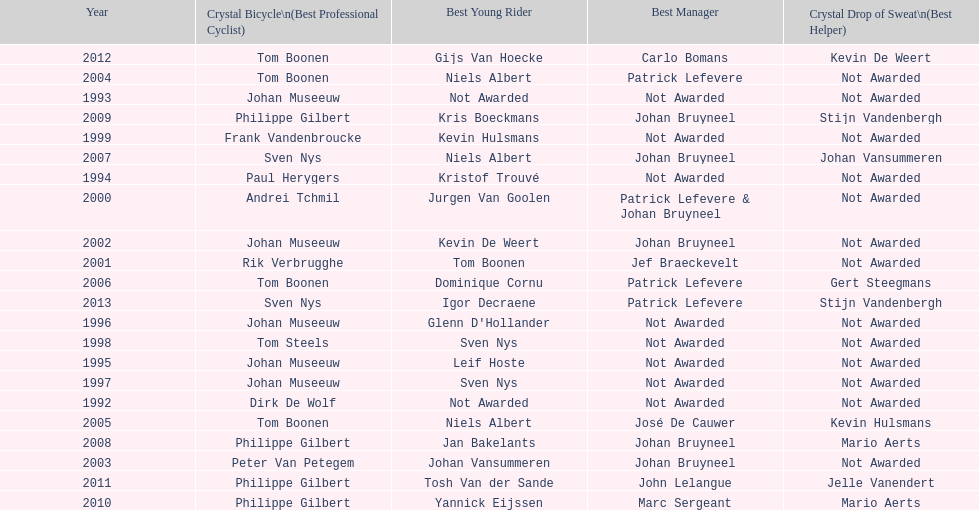What is the average number of times johan museeuw starred? 5. 